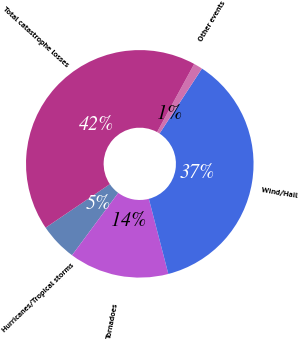<chart> <loc_0><loc_0><loc_500><loc_500><pie_chart><fcel>Hurricanes/Tropical storms<fcel>Tornadoes<fcel>Wind/Hail<fcel>Other events<fcel>Total catastrophe losses<nl><fcel>5.37%<fcel>14.19%<fcel>36.76%<fcel>1.26%<fcel>42.42%<nl></chart> 